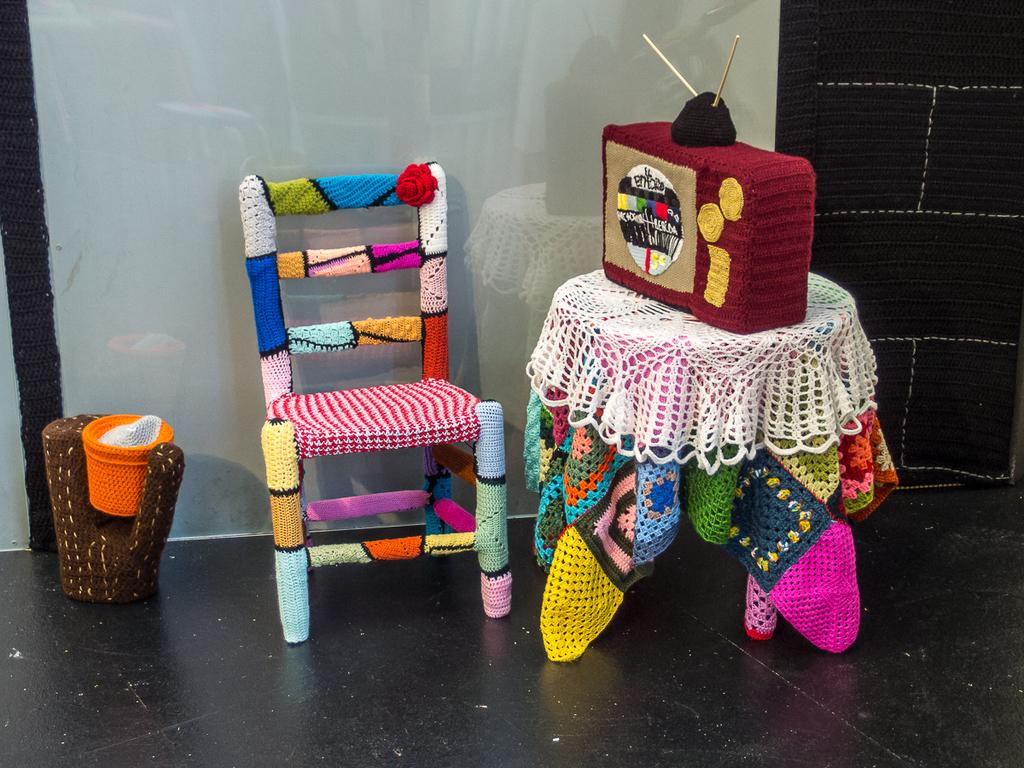What type of chair is in the image? There is a colorful chair in the image. What material is the chair made of? The chair is made of wool. What other furniture is present in the image? There is a table in the image. What material is the table made of? The table is made of wool. What electronic device can be seen in the image? There is a television in the image. What material is the television made of? The television is made of wool. Are there any decorative items in the image? Yes, there is a flower pot in the image. What material is the flower pot made of? The flower pot is made of wool. What surface is visible in the image? The floor is visible in the image. How many cacti are present in the image? There are no cacti present in the image. What type of beef is being cooked on the whiteboard in the image? There is no beef or cooking activity present in the image. 